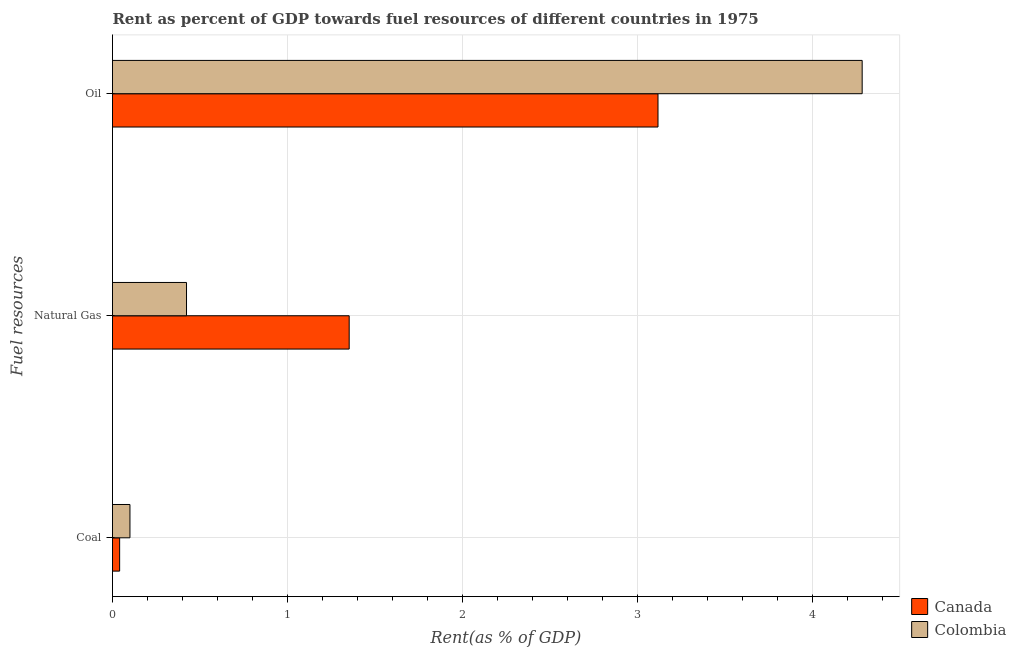Are the number of bars per tick equal to the number of legend labels?
Your answer should be compact. Yes. How many bars are there on the 3rd tick from the top?
Keep it short and to the point. 2. What is the label of the 2nd group of bars from the top?
Provide a succinct answer. Natural Gas. What is the rent towards natural gas in Canada?
Provide a succinct answer. 1.35. Across all countries, what is the maximum rent towards natural gas?
Provide a succinct answer. 1.35. Across all countries, what is the minimum rent towards coal?
Offer a terse response. 0.04. What is the total rent towards coal in the graph?
Make the answer very short. 0.14. What is the difference between the rent towards coal in Canada and that in Colombia?
Ensure brevity in your answer.  -0.06. What is the difference between the rent towards coal in Colombia and the rent towards oil in Canada?
Give a very brief answer. -3.02. What is the average rent towards coal per country?
Your answer should be very brief. 0.07. What is the difference between the rent towards natural gas and rent towards coal in Canada?
Offer a terse response. 1.31. What is the ratio of the rent towards natural gas in Colombia to that in Canada?
Give a very brief answer. 0.31. Is the rent towards oil in Canada less than that in Colombia?
Offer a very short reply. Yes. Is the difference between the rent towards oil in Colombia and Canada greater than the difference between the rent towards natural gas in Colombia and Canada?
Offer a very short reply. Yes. What is the difference between the highest and the second highest rent towards coal?
Give a very brief answer. 0.06. What is the difference between the highest and the lowest rent towards coal?
Provide a succinct answer. 0.06. In how many countries, is the rent towards natural gas greater than the average rent towards natural gas taken over all countries?
Offer a very short reply. 1. Is the sum of the rent towards oil in Canada and Colombia greater than the maximum rent towards coal across all countries?
Ensure brevity in your answer.  Yes. What does the 2nd bar from the top in Coal represents?
Make the answer very short. Canada. What does the 2nd bar from the bottom in Natural Gas represents?
Your response must be concise. Colombia. Is it the case that in every country, the sum of the rent towards coal and rent towards natural gas is greater than the rent towards oil?
Provide a short and direct response. No. How many countries are there in the graph?
Your response must be concise. 2. Does the graph contain grids?
Offer a very short reply. Yes. How many legend labels are there?
Your answer should be compact. 2. What is the title of the graph?
Make the answer very short. Rent as percent of GDP towards fuel resources of different countries in 1975. What is the label or title of the X-axis?
Provide a succinct answer. Rent(as % of GDP). What is the label or title of the Y-axis?
Provide a succinct answer. Fuel resources. What is the Rent(as % of GDP) in Canada in Coal?
Ensure brevity in your answer.  0.04. What is the Rent(as % of GDP) in Colombia in Coal?
Your answer should be very brief. 0.1. What is the Rent(as % of GDP) in Canada in Natural Gas?
Keep it short and to the point. 1.35. What is the Rent(as % of GDP) of Colombia in Natural Gas?
Offer a terse response. 0.42. What is the Rent(as % of GDP) in Canada in Oil?
Your answer should be very brief. 3.12. What is the Rent(as % of GDP) of Colombia in Oil?
Your answer should be very brief. 4.28. Across all Fuel resources, what is the maximum Rent(as % of GDP) in Canada?
Ensure brevity in your answer.  3.12. Across all Fuel resources, what is the maximum Rent(as % of GDP) in Colombia?
Provide a short and direct response. 4.28. Across all Fuel resources, what is the minimum Rent(as % of GDP) of Canada?
Keep it short and to the point. 0.04. Across all Fuel resources, what is the minimum Rent(as % of GDP) in Colombia?
Your response must be concise. 0.1. What is the total Rent(as % of GDP) in Canada in the graph?
Offer a very short reply. 4.51. What is the total Rent(as % of GDP) of Colombia in the graph?
Make the answer very short. 4.81. What is the difference between the Rent(as % of GDP) of Canada in Coal and that in Natural Gas?
Give a very brief answer. -1.31. What is the difference between the Rent(as % of GDP) in Colombia in Coal and that in Natural Gas?
Ensure brevity in your answer.  -0.32. What is the difference between the Rent(as % of GDP) in Canada in Coal and that in Oil?
Keep it short and to the point. -3.08. What is the difference between the Rent(as % of GDP) in Colombia in Coal and that in Oil?
Your answer should be very brief. -4.18. What is the difference between the Rent(as % of GDP) of Canada in Natural Gas and that in Oil?
Your answer should be compact. -1.76. What is the difference between the Rent(as % of GDP) of Colombia in Natural Gas and that in Oil?
Ensure brevity in your answer.  -3.86. What is the difference between the Rent(as % of GDP) in Canada in Coal and the Rent(as % of GDP) in Colombia in Natural Gas?
Make the answer very short. -0.38. What is the difference between the Rent(as % of GDP) of Canada in Coal and the Rent(as % of GDP) of Colombia in Oil?
Ensure brevity in your answer.  -4.24. What is the difference between the Rent(as % of GDP) in Canada in Natural Gas and the Rent(as % of GDP) in Colombia in Oil?
Your answer should be very brief. -2.93. What is the average Rent(as % of GDP) in Canada per Fuel resources?
Provide a succinct answer. 1.5. What is the average Rent(as % of GDP) in Colombia per Fuel resources?
Offer a very short reply. 1.6. What is the difference between the Rent(as % of GDP) in Canada and Rent(as % of GDP) in Colombia in Coal?
Keep it short and to the point. -0.06. What is the difference between the Rent(as % of GDP) in Canada and Rent(as % of GDP) in Colombia in Natural Gas?
Ensure brevity in your answer.  0.93. What is the difference between the Rent(as % of GDP) of Canada and Rent(as % of GDP) of Colombia in Oil?
Offer a very short reply. -1.17. What is the ratio of the Rent(as % of GDP) in Canada in Coal to that in Natural Gas?
Give a very brief answer. 0.03. What is the ratio of the Rent(as % of GDP) of Colombia in Coal to that in Natural Gas?
Give a very brief answer. 0.24. What is the ratio of the Rent(as % of GDP) of Canada in Coal to that in Oil?
Ensure brevity in your answer.  0.01. What is the ratio of the Rent(as % of GDP) of Colombia in Coal to that in Oil?
Provide a short and direct response. 0.02. What is the ratio of the Rent(as % of GDP) in Canada in Natural Gas to that in Oil?
Provide a succinct answer. 0.43. What is the ratio of the Rent(as % of GDP) of Colombia in Natural Gas to that in Oil?
Keep it short and to the point. 0.1. What is the difference between the highest and the second highest Rent(as % of GDP) in Canada?
Ensure brevity in your answer.  1.76. What is the difference between the highest and the second highest Rent(as % of GDP) of Colombia?
Offer a very short reply. 3.86. What is the difference between the highest and the lowest Rent(as % of GDP) in Canada?
Keep it short and to the point. 3.08. What is the difference between the highest and the lowest Rent(as % of GDP) in Colombia?
Your answer should be very brief. 4.18. 